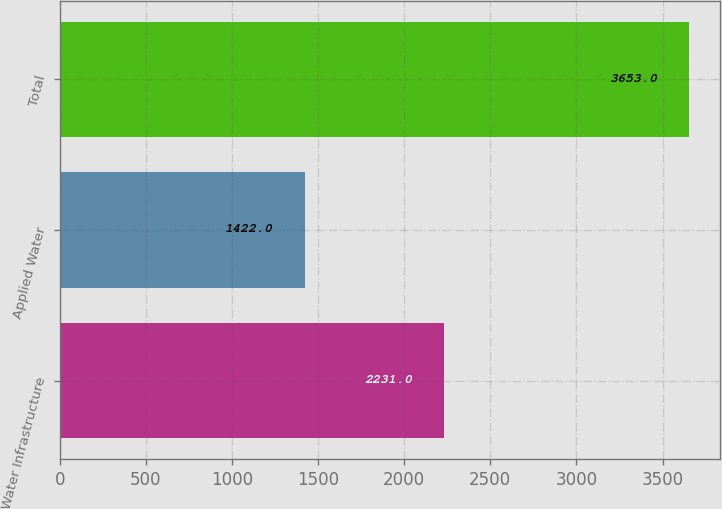<chart> <loc_0><loc_0><loc_500><loc_500><bar_chart><fcel>Water Infrastructure<fcel>Applied Water<fcel>Total<nl><fcel>2231<fcel>1422<fcel>3653<nl></chart> 